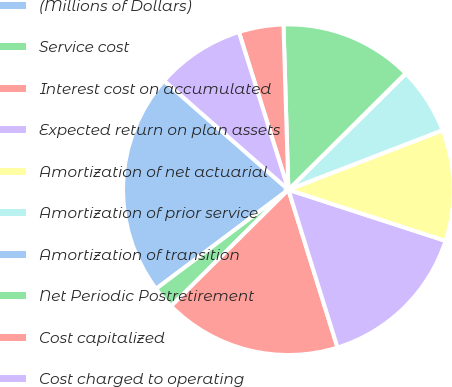<chart> <loc_0><loc_0><loc_500><loc_500><pie_chart><fcel>(Millions of Dollars)<fcel>Service cost<fcel>Interest cost on accumulated<fcel>Expected return on plan assets<fcel>Amortization of net actuarial<fcel>Amortization of prior service<fcel>Amortization of transition<fcel>Net Periodic Postretirement<fcel>Cost capitalized<fcel>Cost charged to operating<nl><fcel>21.69%<fcel>2.21%<fcel>17.36%<fcel>15.19%<fcel>10.87%<fcel>6.54%<fcel>0.04%<fcel>13.03%<fcel>4.37%<fcel>8.7%<nl></chart> 